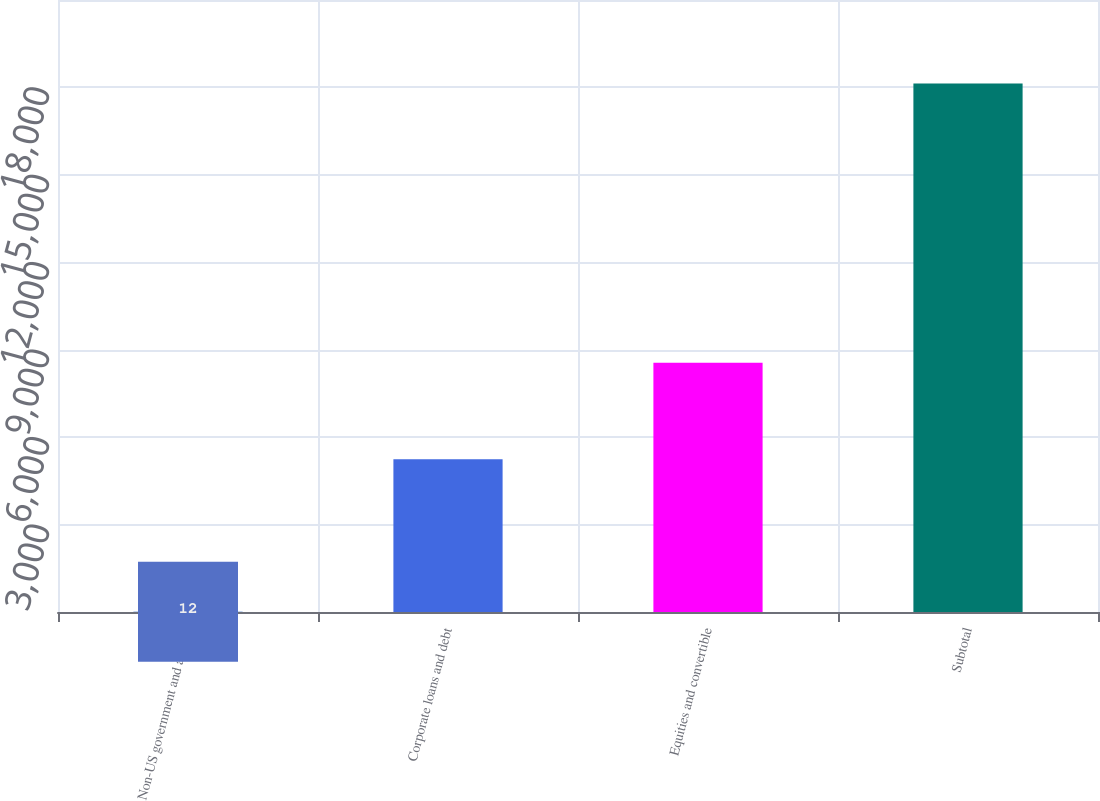Convert chart. <chart><loc_0><loc_0><loc_500><loc_500><bar_chart><fcel>Non-US government and agency<fcel>Corporate loans and debt<fcel>Equities and convertible<fcel>Subtotal<nl><fcel>12<fcel>5242<fcel>8549<fcel>18131<nl></chart> 